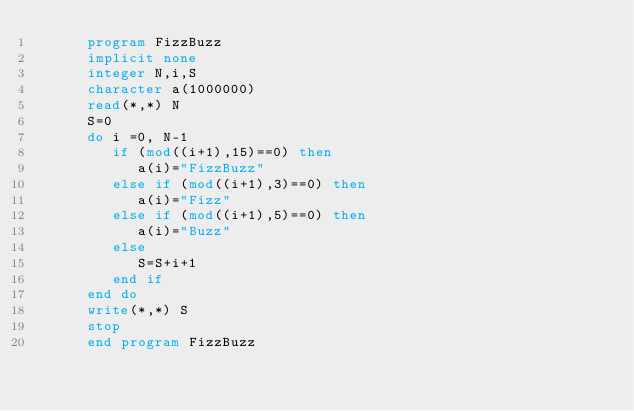Convert code to text. <code><loc_0><loc_0><loc_500><loc_500><_FORTRAN_>      program FizzBuzz
      implicit none
      integer N,i,S
      character a(1000000)
      read(*,*) N
      S=0
      do i =0, N-1
         if (mod((i+1),15)==0) then
            a(i)="FizzBuzz"
         else if (mod((i+1),3)==0) then
            a(i)="Fizz"
         else if (mod((i+1),5)==0) then
            a(i)="Buzz"
         else 
            S=S+i+1
         end if
      end do
      write(*,*) S
      stop 
      end program FizzBuzz
</code> 